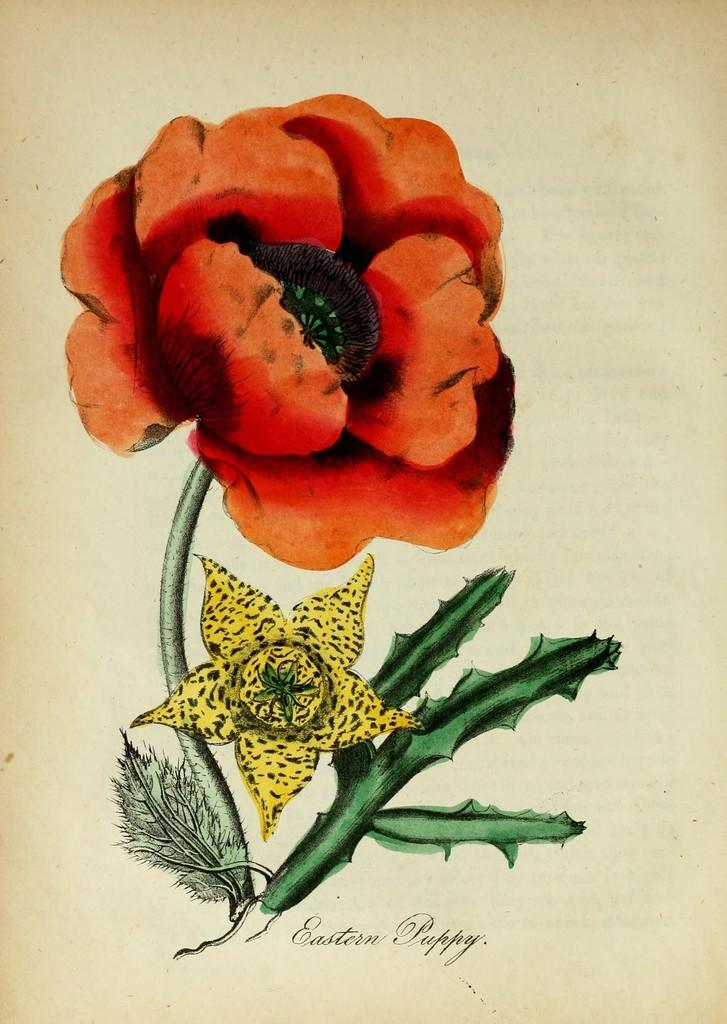What is depicted in the painting in the image? There is a painting of flowers in the image. What colors are the flowers in the painting? The colors of the flowers in the painting are orange and yellow. Is there any text associated with the painting in the image? Yes, there is text written on the painting or near it. Can you see any fairies flying around the flowers in the painting? There are no fairies present in the image; the painting only depicts flowers. 